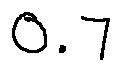Convert formula to latex. <formula><loc_0><loc_0><loc_500><loc_500>0 . 7</formula> 